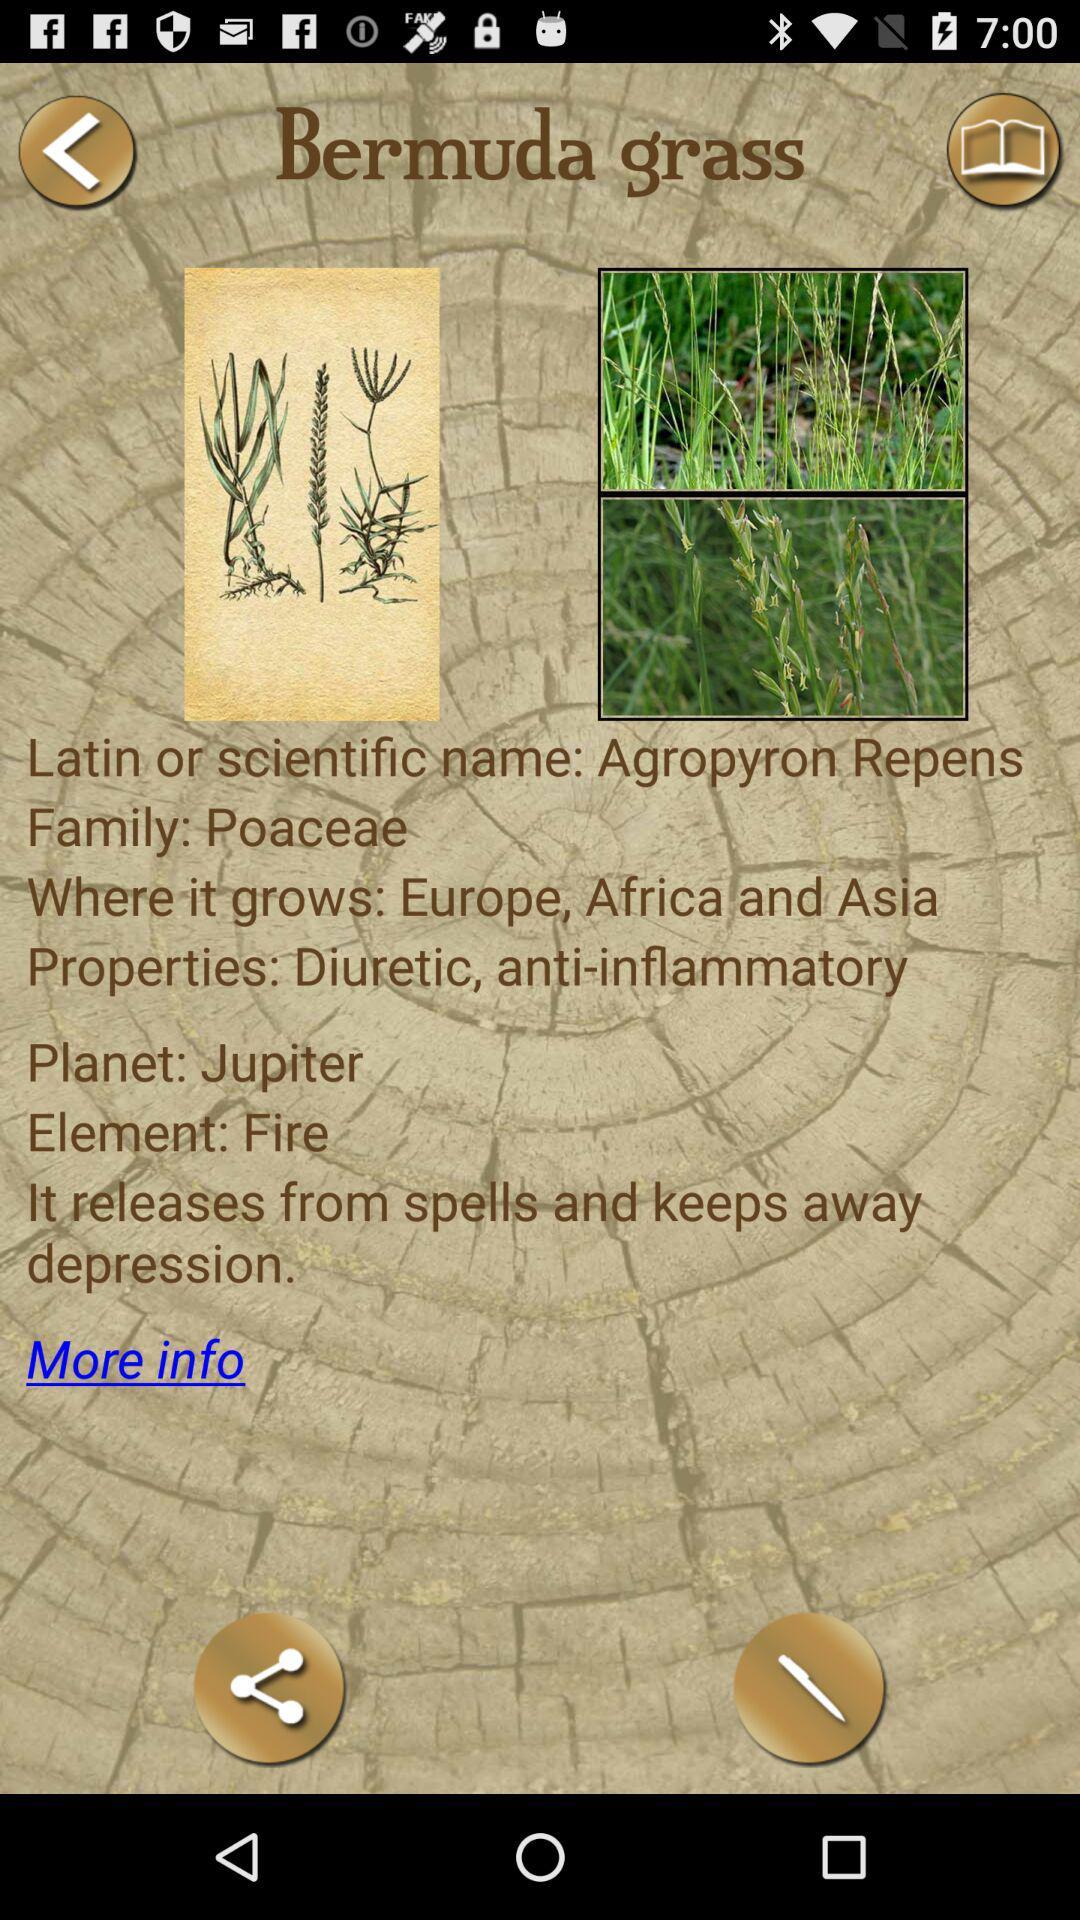What are the properties of Bermuda grass? The properties are "Diuretic, anti-inflammatory". 